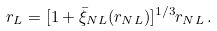<formula> <loc_0><loc_0><loc_500><loc_500>r _ { L } = [ 1 + \bar { \xi } _ { N L } ( r _ { N L } ) ] ^ { 1 / 3 } r _ { N L } \, .</formula> 